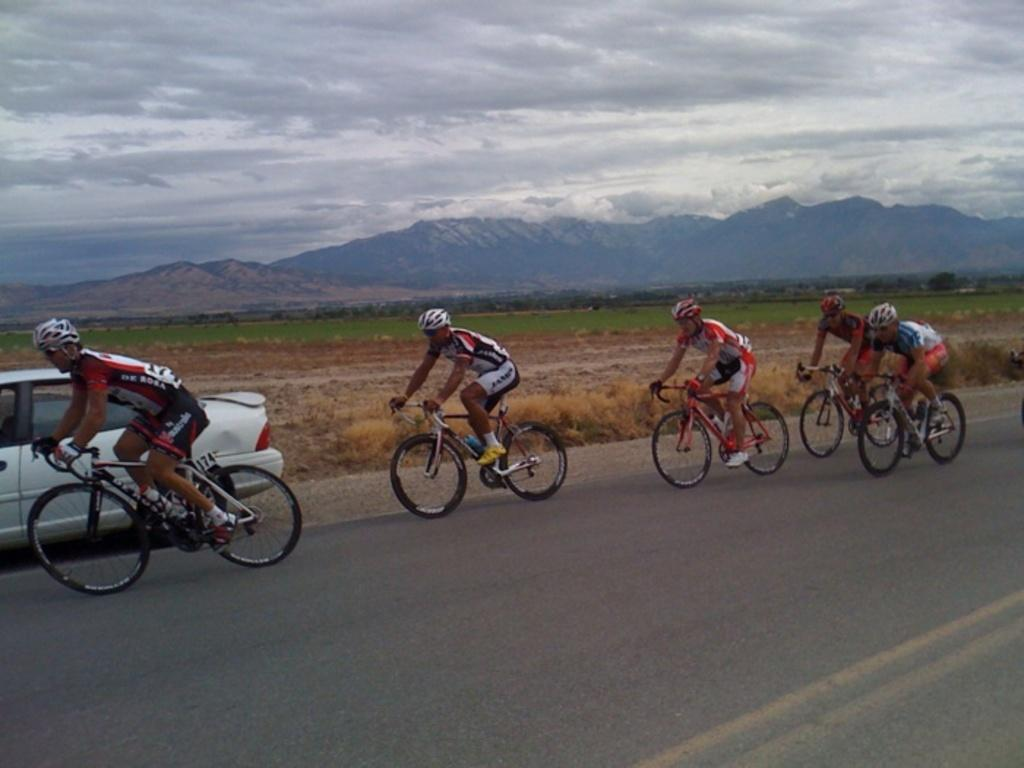What is the main subject of the image? The main subject of the image is a car. Can you describe the people in the image? There are five men in the image, and they are wearing helmets and shoes. What are the men doing in the image? The men are riding bicycles in the image. Where are the bicycles located? The bicycles are on the road in the image. What can be seen in the background of the image? There is grass, mountains, and the sky visible in the background of the image. What is the condition of the sky in the image? The sky is visible with clouds in the background of the image. What type of watch is the kitten wearing in the image? There is no kitten or watch present in the image. What is the army doing in the image? There is no army or military activity depicted in the image. 